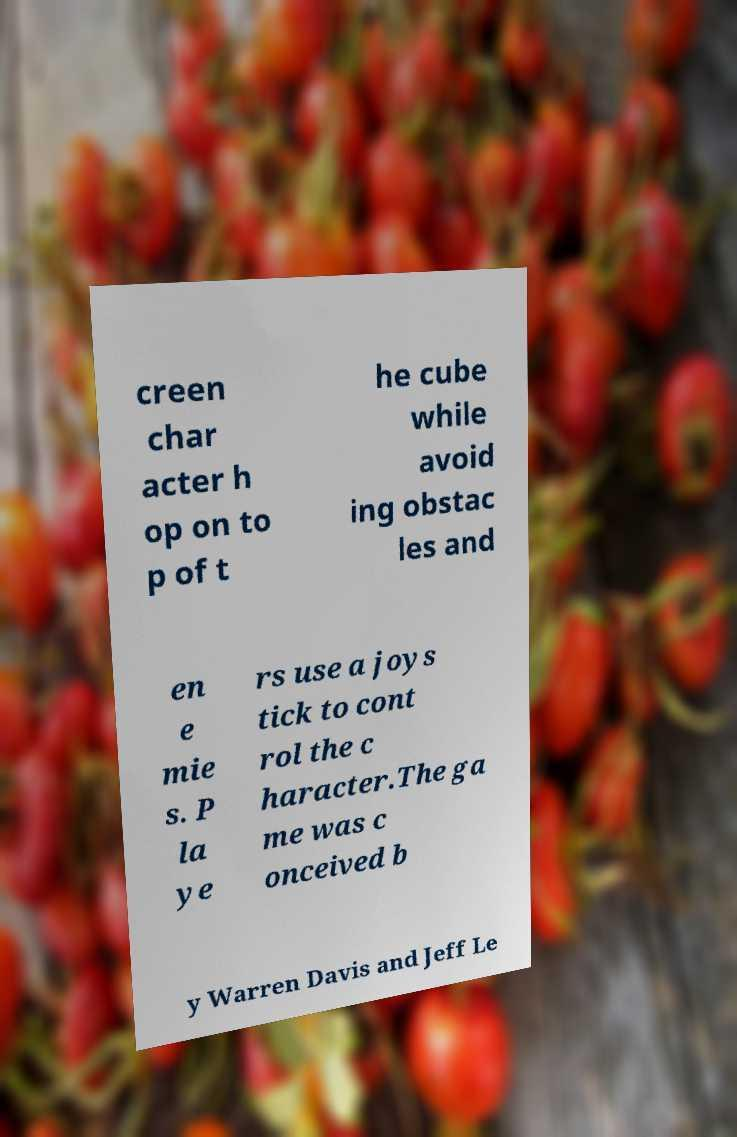Can you accurately transcribe the text from the provided image for me? creen char acter h op on to p of t he cube while avoid ing obstac les and en e mie s. P la ye rs use a joys tick to cont rol the c haracter.The ga me was c onceived b y Warren Davis and Jeff Le 